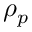Convert formula to latex. <formula><loc_0><loc_0><loc_500><loc_500>\rho _ { p }</formula> 